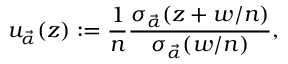<formula> <loc_0><loc_0><loc_500><loc_500>u _ { \vec { \alpha } } ( z ) \colon = \frac { 1 } { n } \frac { \sigma _ { \vec { \alpha } } ( z + w / n ) } { \sigma _ { \vec { \alpha } } ( w / n ) } ,</formula> 